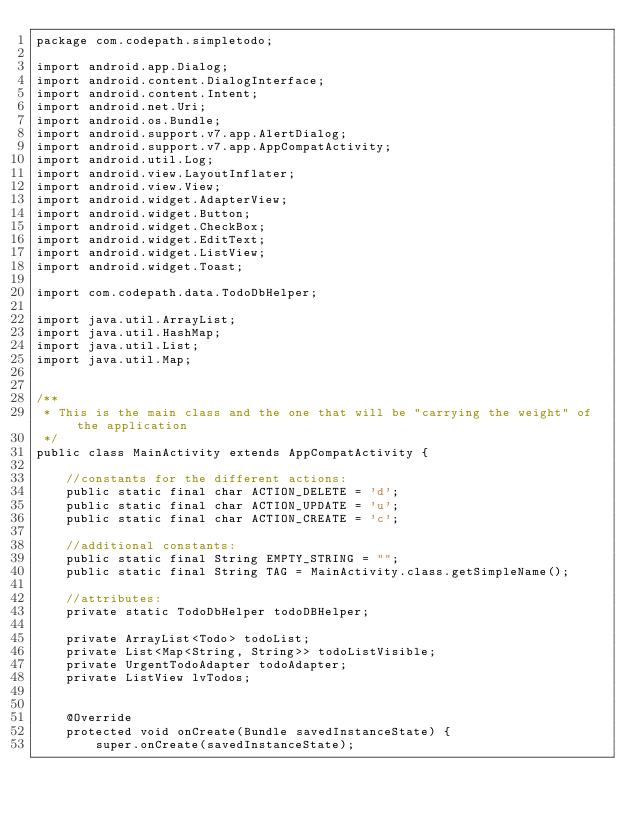<code> <loc_0><loc_0><loc_500><loc_500><_Java_>package com.codepath.simpletodo;

import android.app.Dialog;
import android.content.DialogInterface;
import android.content.Intent;
import android.net.Uri;
import android.os.Bundle;
import android.support.v7.app.AlertDialog;
import android.support.v7.app.AppCompatActivity;
import android.util.Log;
import android.view.LayoutInflater;
import android.view.View;
import android.widget.AdapterView;
import android.widget.Button;
import android.widget.CheckBox;
import android.widget.EditText;
import android.widget.ListView;
import android.widget.Toast;

import com.codepath.data.TodoDbHelper;

import java.util.ArrayList;
import java.util.HashMap;
import java.util.List;
import java.util.Map;


/**
 * This is the main class and the one that will be "carrying the weight" of the application
 */
public class MainActivity extends AppCompatActivity {

    //constants for the different actions:
    public static final char ACTION_DELETE = 'd';
    public static final char ACTION_UPDATE = 'u';
    public static final char ACTION_CREATE = 'c';

    //additional constants:
    public static final String EMPTY_STRING = "";
    public static final String TAG = MainActivity.class.getSimpleName();

    //attributes:
    private static TodoDbHelper todoDBHelper;

    private ArrayList<Todo> todoList;
    private List<Map<String, String>> todoListVisible;
    private UrgentTodoAdapter todoAdapter;
    private ListView lvTodos;


    @Override
    protected void onCreate(Bundle savedInstanceState) {
        super.onCreate(savedInstanceState);
</code> 